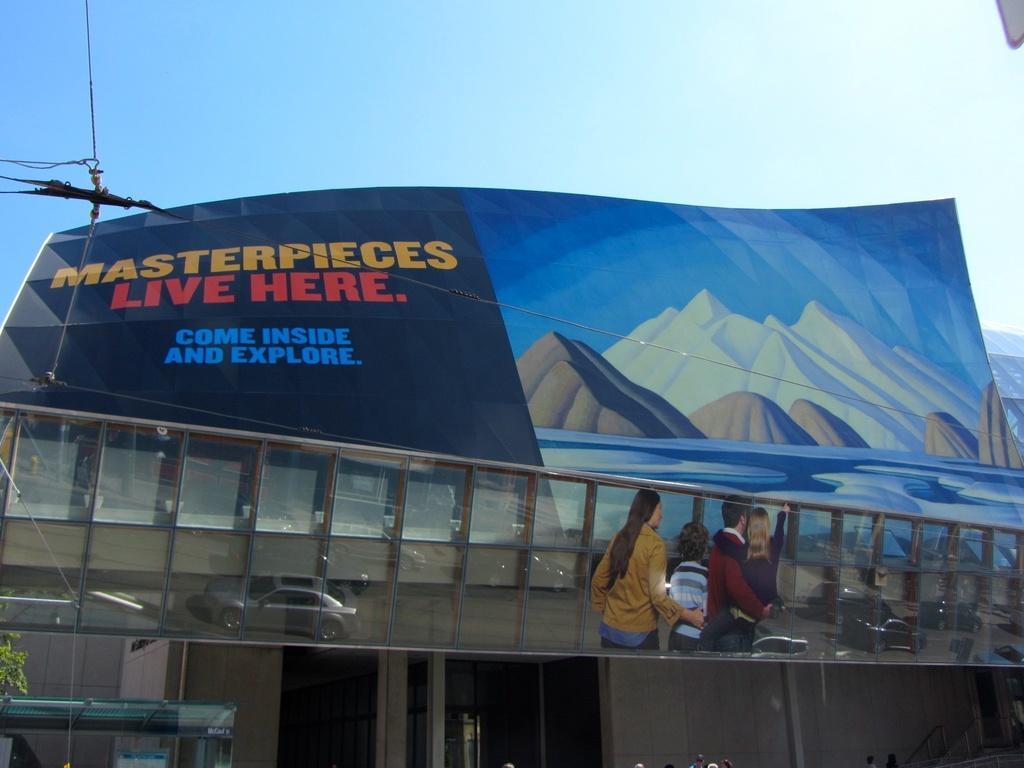Could you give a brief overview of what you see in this image? In this image there is a hoarding in the middle. Below the hoarding there are glasses on which we can see the reflections of cars and four people. On the left side top there is a wire which is tied to the hoarding. In the background it looks like a building. On the left side bottom there is a pole. Beside the pole there is a tree. 